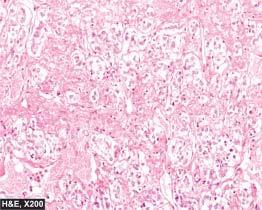re the tumour cells large, polyhedral and pleomorphic having abundant granular cytoplasm?
Answer the question using a single word or phrase. Yes 